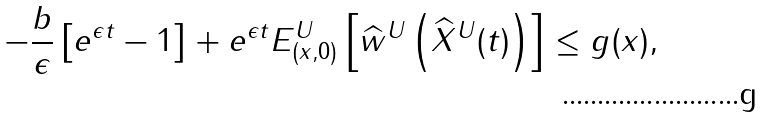Convert formula to latex. <formula><loc_0><loc_0><loc_500><loc_500>- \frac { b } { \epsilon } \left [ e ^ { \epsilon t } - 1 \right ] + e ^ { \epsilon t } E ^ { U } _ { ( x , 0 ) } \left [ \widehat { w } ^ { U } \left ( \widehat { X } ^ { U } ( t ) \right ) \right ] \leq g ( x ) ,</formula> 